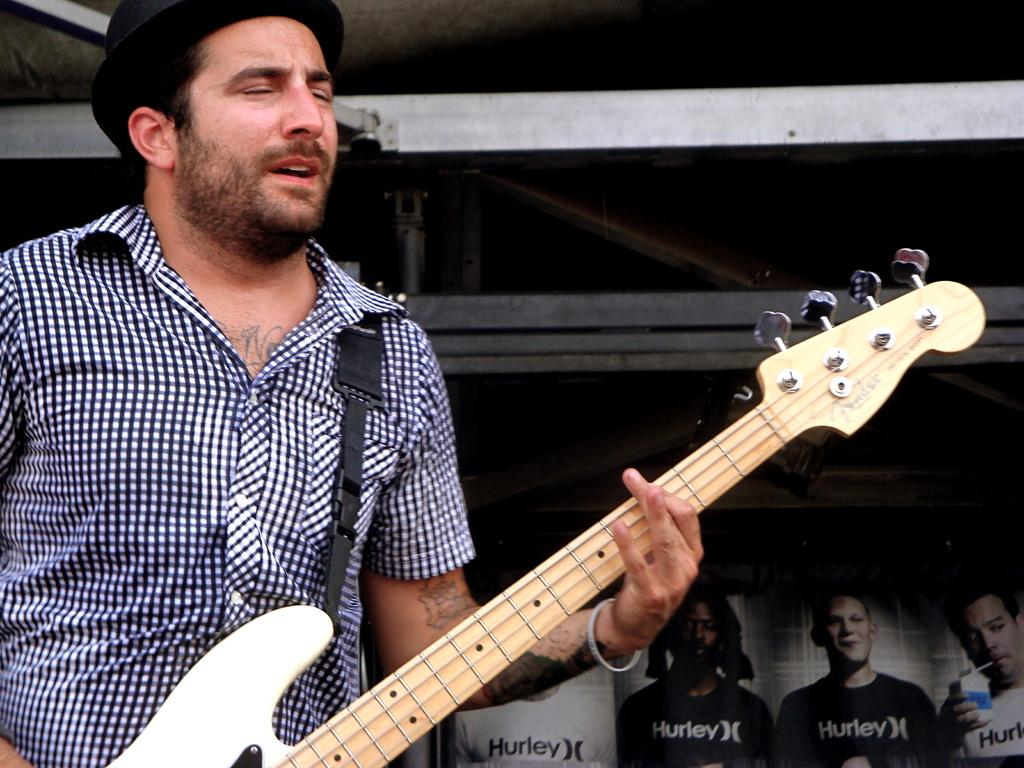What is the man in the image doing? The man is playing the guitar. What object is the man holding in the image? The man is holding a guitar. What can be seen in the background of the image? There are images of persons in the background of the image. How does the man fall off the stage in the image? There is no indication in the image that the man is falling off the stage or that a stage is even present. 